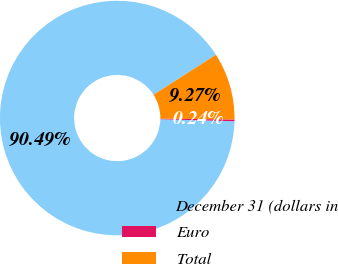Convert chart. <chart><loc_0><loc_0><loc_500><loc_500><pie_chart><fcel>December 31 (dollars in<fcel>Euro<fcel>Total<nl><fcel>90.49%<fcel>0.24%<fcel>9.27%<nl></chart> 